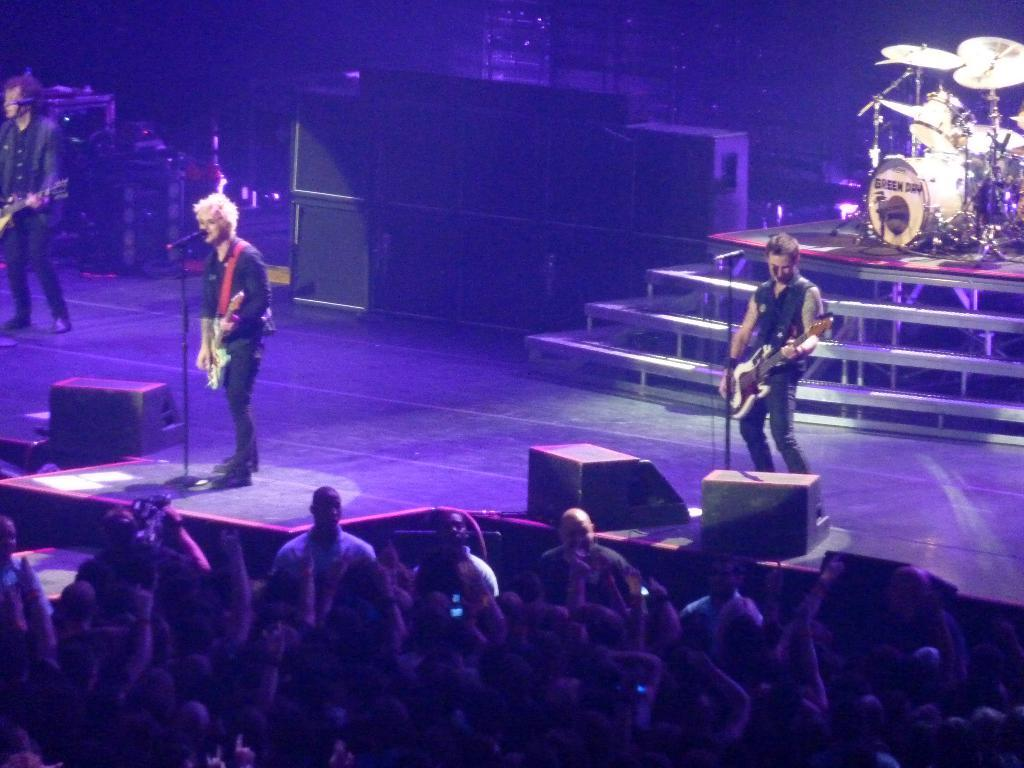How many people are playing the guitar in the image? There are three people playing the guitar in the image. Where are the three people playing the guitar located? They are on a stage. What other musical instruments can be seen in the background of the image? There is a drum and musical plates in the background. Who is the audience for the performance in the image? There is a crowd in front of the stage. Can you see a donkey playing the drums in the background of the image? No, there is no donkey or any animal present in the image. Are there any goldfish swimming in the background of the image? No, there are no goldfish or any aquatic animals present in the image. 